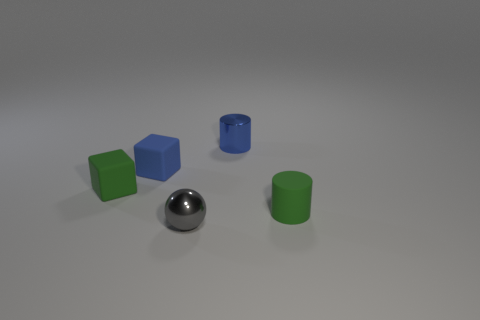There is a blue object that is behind the small blue rubber block; does it have the same shape as the tiny blue rubber thing?
Provide a short and direct response. No. There is another cylinder that is the same size as the green matte cylinder; what is it made of?
Ensure brevity in your answer.  Metal. Are there an equal number of matte cubes behind the small blue block and tiny gray metal objects in front of the green matte cube?
Offer a very short reply. No. What number of small matte cubes are behind the small matte thing behind the green thing that is on the left side of the tiny gray sphere?
Provide a succinct answer. 0. Do the tiny matte cylinder and the tiny matte block right of the small green matte block have the same color?
Ensure brevity in your answer.  No. There is a cylinder that is the same material as the blue block; what size is it?
Offer a terse response. Small. Is the number of tiny blue rubber objects that are on the left side of the blue cylinder greater than the number of tiny balls?
Provide a short and direct response. No. There is a green thing that is behind the tiny green object to the right of the tiny shiny object on the left side of the metal cylinder; what is it made of?
Make the answer very short. Rubber. Do the tiny gray sphere and the tiny green object left of the tiny metal sphere have the same material?
Give a very brief answer. No. What material is the other thing that is the same shape as the blue rubber object?
Your answer should be compact. Rubber. 